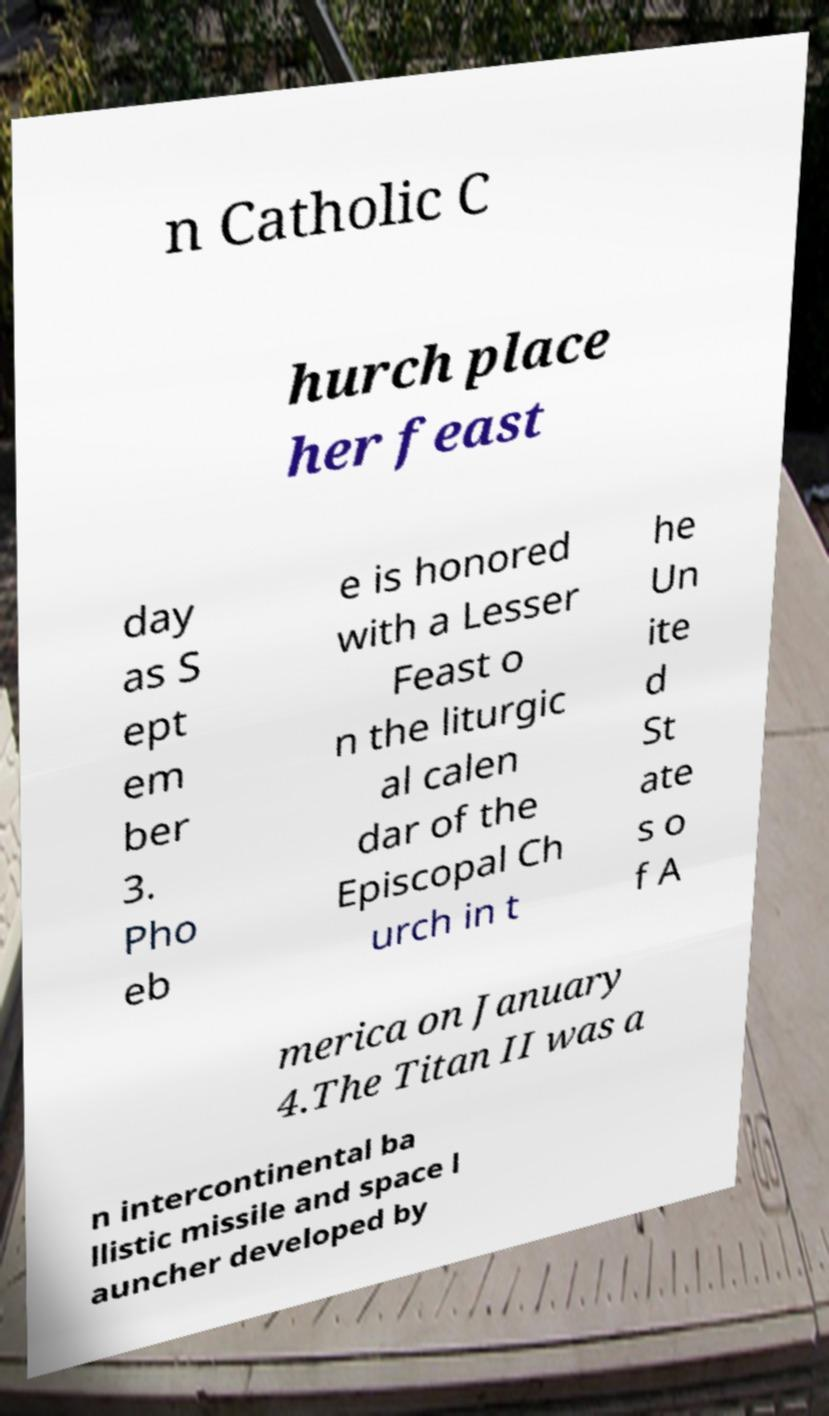I need the written content from this picture converted into text. Can you do that? n Catholic C hurch place her feast day as S ept em ber 3. Pho eb e is honored with a Lesser Feast o n the liturgic al calen dar of the Episcopal Ch urch in t he Un ite d St ate s o f A merica on January 4.The Titan II was a n intercontinental ba llistic missile and space l auncher developed by 